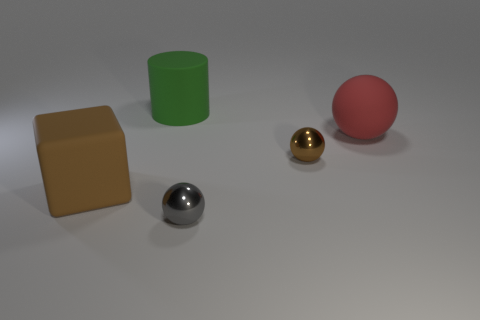Subtract all matte balls. How many balls are left? 2 Subtract 1 cylinders. How many cylinders are left? 0 Add 1 tiny matte things. How many objects exist? 6 Subtract all cubes. How many objects are left? 4 Subtract all red balls. How many balls are left? 2 Subtract all cyan spheres. Subtract all cyan blocks. How many spheres are left? 3 Subtract all brown blocks. How many red balls are left? 1 Subtract all brown matte cylinders. Subtract all big rubber blocks. How many objects are left? 4 Add 4 brown matte cubes. How many brown matte cubes are left? 5 Add 2 brown metal things. How many brown metal things exist? 3 